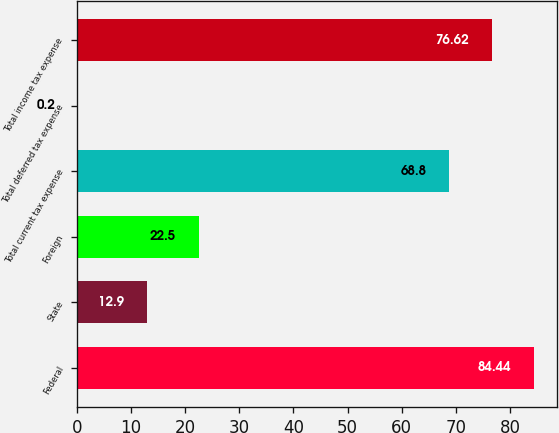Convert chart to OTSL. <chart><loc_0><loc_0><loc_500><loc_500><bar_chart><fcel>Federal<fcel>State<fcel>Foreign<fcel>Total current tax expense<fcel>Total deferred tax expense<fcel>Total income tax expense<nl><fcel>84.44<fcel>12.9<fcel>22.5<fcel>68.8<fcel>0.2<fcel>76.62<nl></chart> 